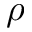<formula> <loc_0><loc_0><loc_500><loc_500>\rho</formula> 